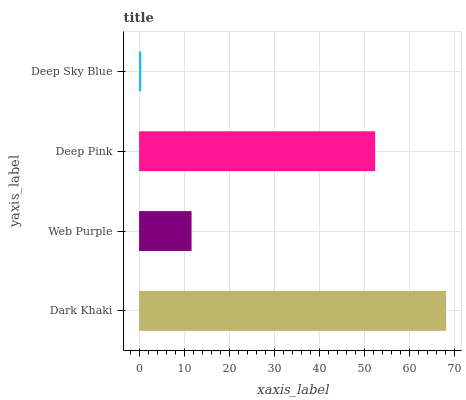Is Deep Sky Blue the minimum?
Answer yes or no. Yes. Is Dark Khaki the maximum?
Answer yes or no. Yes. Is Web Purple the minimum?
Answer yes or no. No. Is Web Purple the maximum?
Answer yes or no. No. Is Dark Khaki greater than Web Purple?
Answer yes or no. Yes. Is Web Purple less than Dark Khaki?
Answer yes or no. Yes. Is Web Purple greater than Dark Khaki?
Answer yes or no. No. Is Dark Khaki less than Web Purple?
Answer yes or no. No. Is Deep Pink the high median?
Answer yes or no. Yes. Is Web Purple the low median?
Answer yes or no. Yes. Is Web Purple the high median?
Answer yes or no. No. Is Dark Khaki the low median?
Answer yes or no. No. 